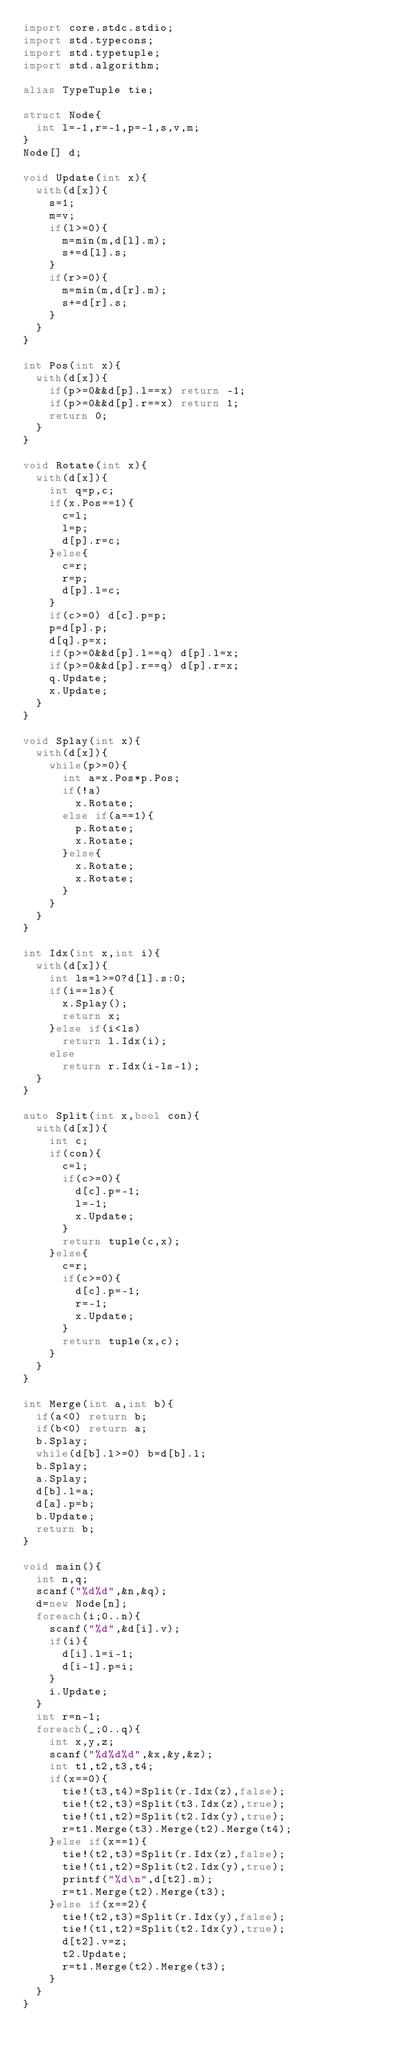<code> <loc_0><loc_0><loc_500><loc_500><_D_>import core.stdc.stdio;
import std.typecons;
import std.typetuple;
import std.algorithm;

alias TypeTuple tie;

struct Node{
	int l=-1,r=-1,p=-1,s,v,m;
}
Node[] d;

void Update(int x){
	with(d[x]){
		s=1;
		m=v;
		if(l>=0){
			m=min(m,d[l].m);
			s+=d[l].s;
		}
		if(r>=0){
			m=min(m,d[r].m);
			s+=d[r].s;
		}
	}
}

int Pos(int x){
	with(d[x]){
		if(p>=0&&d[p].l==x) return -1;
		if(p>=0&&d[p].r==x) return 1;
		return 0;
	}
}

void Rotate(int x){
	with(d[x]){
		int q=p,c;
		if(x.Pos==1){
			c=l;
			l=p;
			d[p].r=c;
		}else{
			c=r;
			r=p;
			d[p].l=c;
		}
		if(c>=0) d[c].p=p;
		p=d[p].p;
		d[q].p=x;
		if(p>=0&&d[p].l==q) d[p].l=x;
		if(p>=0&&d[p].r==q) d[p].r=x;
		q.Update;
		x.Update;
	}
}

void Splay(int x){
	with(d[x]){
		while(p>=0){
			int a=x.Pos*p.Pos;
			if(!a)
				x.Rotate;
			else if(a==1){
				p.Rotate;
				x.Rotate;
			}else{
				x.Rotate;
				x.Rotate;
			}
		}
	}
}

int Idx(int x,int i){
	with(d[x]){
		int ls=l>=0?d[l].s:0;
		if(i==ls){
			x.Splay();
			return x;
		}else if(i<ls)
			return l.Idx(i);
		else
			return r.Idx(i-ls-1);
	}
}

auto Split(int x,bool con){
	with(d[x]){
		int c;
		if(con){
			c=l;
			if(c>=0){
				d[c].p=-1;
				l=-1;
				x.Update;
			}
			return tuple(c,x);
		}else{
			c=r;
			if(c>=0){
				d[c].p=-1;
				r=-1;
				x.Update;
			}
			return tuple(x,c);
		}
	}
}

int Merge(int a,int b){
	if(a<0) return b;
	if(b<0) return a;
	b.Splay;
	while(d[b].l>=0) b=d[b].l;
	b.Splay;
	a.Splay;
	d[b].l=a;
	d[a].p=b;
	b.Update;
	return b;
}

void main(){
	int n,q;
	scanf("%d%d",&n,&q);
	d=new Node[n];
	foreach(i;0..n){
		scanf("%d",&d[i].v);
		if(i){
			d[i].l=i-1;
			d[i-1].p=i;
		}
		i.Update;
	}
	int r=n-1;
	foreach(_;0..q){
		int x,y,z;
		scanf("%d%d%d",&x,&y,&z);
		int t1,t2,t3,t4;
		if(x==0){
			tie!(t3,t4)=Split(r.Idx(z),false);
			tie!(t2,t3)=Split(t3.Idx(z),true);
			tie!(t1,t2)=Split(t2.Idx(y),true);
			r=t1.Merge(t3).Merge(t2).Merge(t4);
		}else if(x==1){
			tie!(t2,t3)=Split(r.Idx(z),false);
			tie!(t1,t2)=Split(t2.Idx(y),true);
			printf("%d\n",d[t2].m);
			r=t1.Merge(t2).Merge(t3);
		}else if(x==2){
			tie!(t2,t3)=Split(r.Idx(y),false);
			tie!(t1,t2)=Split(t2.Idx(y),true);
			d[t2].v=z;
			t2.Update;
			r=t1.Merge(t2).Merge(t3);
		}
	}
}</code> 